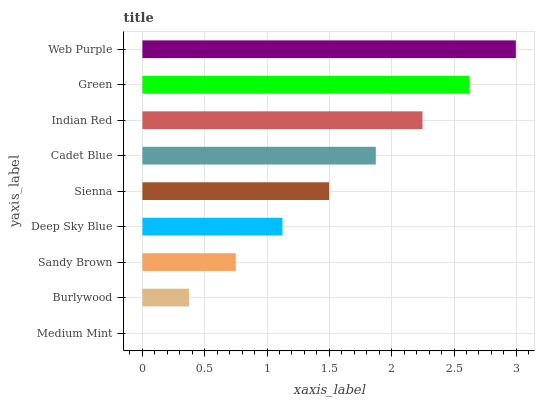Is Medium Mint the minimum?
Answer yes or no. Yes. Is Web Purple the maximum?
Answer yes or no. Yes. Is Burlywood the minimum?
Answer yes or no. No. Is Burlywood the maximum?
Answer yes or no. No. Is Burlywood greater than Medium Mint?
Answer yes or no. Yes. Is Medium Mint less than Burlywood?
Answer yes or no. Yes. Is Medium Mint greater than Burlywood?
Answer yes or no. No. Is Burlywood less than Medium Mint?
Answer yes or no. No. Is Sienna the high median?
Answer yes or no. Yes. Is Sienna the low median?
Answer yes or no. Yes. Is Sandy Brown the high median?
Answer yes or no. No. Is Green the low median?
Answer yes or no. No. 